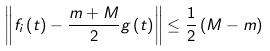Convert formula to latex. <formula><loc_0><loc_0><loc_500><loc_500>\left \| f _ { i } \left ( t \right ) - \frac { m + M } { 2 } g \left ( t \right ) \right \| \leq \frac { 1 } { 2 } \left ( M - m \right )</formula> 